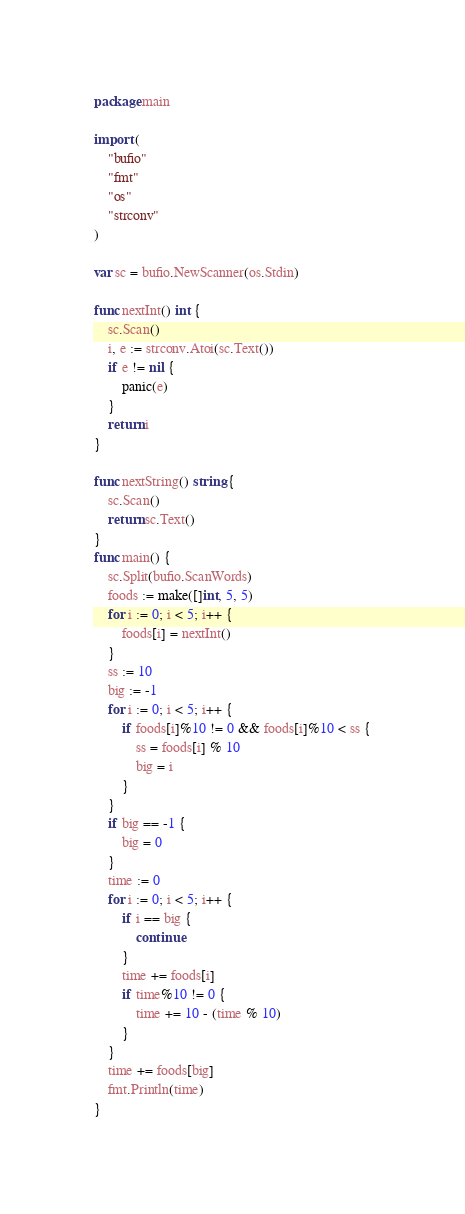Convert code to text. <code><loc_0><loc_0><loc_500><loc_500><_Go_>package main

import (
	"bufio"
	"fmt"
	"os"
	"strconv"
)

var sc = bufio.NewScanner(os.Stdin)

func nextInt() int {
	sc.Scan()
	i, e := strconv.Atoi(sc.Text())
	if e != nil {
		panic(e)
	}
	return i
}

func nextString() string {
	sc.Scan()
	return sc.Text()
}
func main() {
	sc.Split(bufio.ScanWords)
	foods := make([]int, 5, 5)
	for i := 0; i < 5; i++ {
		foods[i] = nextInt()
	}
	ss := 10
	big := -1
	for i := 0; i < 5; i++ {
		if foods[i]%10 != 0 && foods[i]%10 < ss {
			ss = foods[i] % 10
			big = i
		}
	}
	if big == -1 {
		big = 0
	}
	time := 0
	for i := 0; i < 5; i++ {
		if i == big {
			continue
		}
		time += foods[i]
		if time%10 != 0 {
			time += 10 - (time % 10)
		}
	}
	time += foods[big]
	fmt.Println(time)
}
</code> 